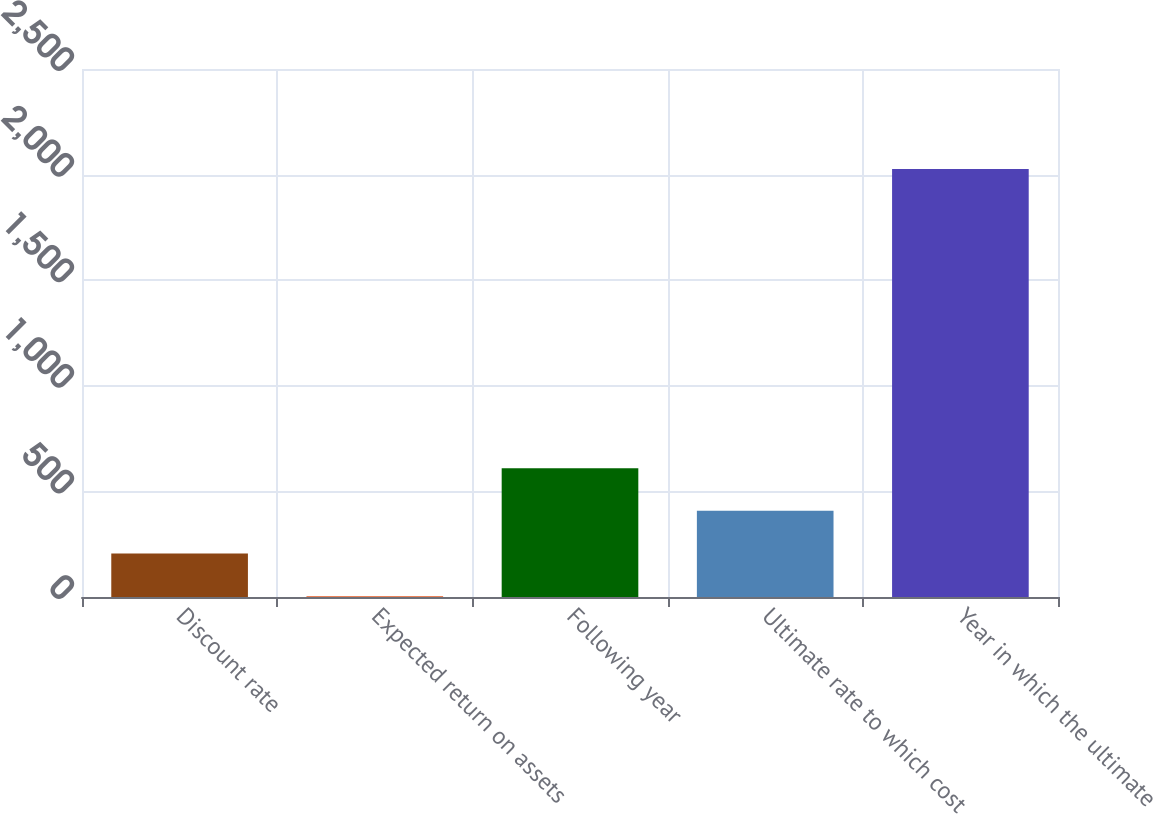Convert chart to OTSL. <chart><loc_0><loc_0><loc_500><loc_500><bar_chart><fcel>Discount rate<fcel>Expected return on assets<fcel>Following year<fcel>Ultimate rate to which cost<fcel>Year in which the ultimate<nl><fcel>205.4<fcel>3<fcel>610.2<fcel>407.8<fcel>2027<nl></chart> 